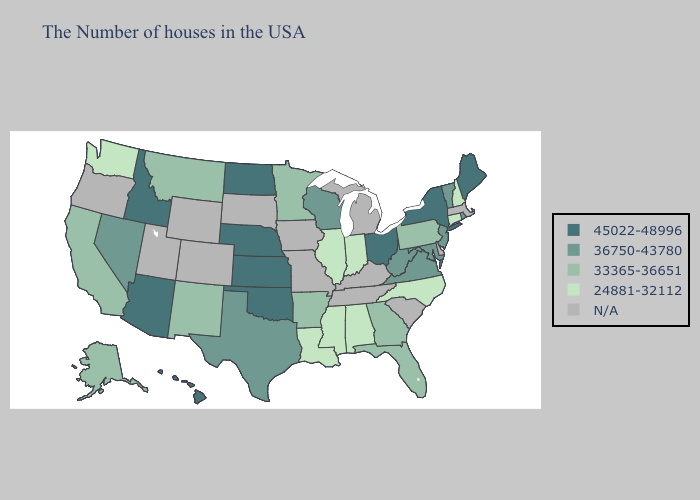Does Maryland have the highest value in the USA?
Be succinct. No. What is the highest value in states that border Missouri?
Be succinct. 45022-48996. Does Nevada have the lowest value in the USA?
Answer briefly. No. Among the states that border South Dakota , does North Dakota have the lowest value?
Give a very brief answer. No. What is the value of Georgia?
Short answer required. 33365-36651. What is the value of California?
Short answer required. 33365-36651. Among the states that border Colorado , which have the highest value?
Write a very short answer. Kansas, Nebraska, Oklahoma, Arizona. Name the states that have a value in the range 36750-43780?
Keep it brief. Rhode Island, Vermont, New Jersey, Maryland, Virginia, West Virginia, Wisconsin, Texas, Nevada. Does Vermont have the highest value in the USA?
Give a very brief answer. No. What is the lowest value in the USA?
Keep it brief. 24881-32112. What is the value of New Jersey?
Write a very short answer. 36750-43780. Among the states that border Alabama , does Mississippi have the highest value?
Short answer required. No. Does Connecticut have the lowest value in the Northeast?
Concise answer only. Yes. What is the lowest value in the USA?
Answer briefly. 24881-32112. 